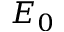Convert formula to latex. <formula><loc_0><loc_0><loc_500><loc_500>E _ { 0 }</formula> 